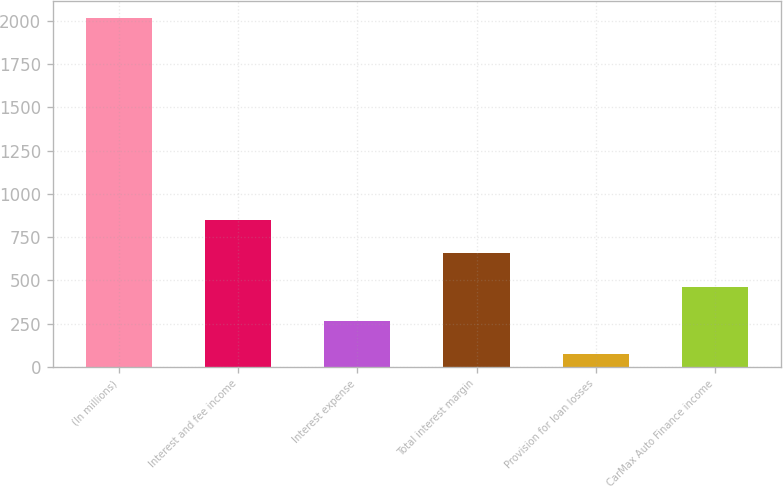Convert chart to OTSL. <chart><loc_0><loc_0><loc_500><loc_500><bar_chart><fcel>(In millions)<fcel>Interest and fee income<fcel>Interest expense<fcel>Total interest margin<fcel>Provision for loan losses<fcel>CarMax Auto Finance income<nl><fcel>2014<fcel>848.92<fcel>266.38<fcel>654.74<fcel>72.2<fcel>460.56<nl></chart> 